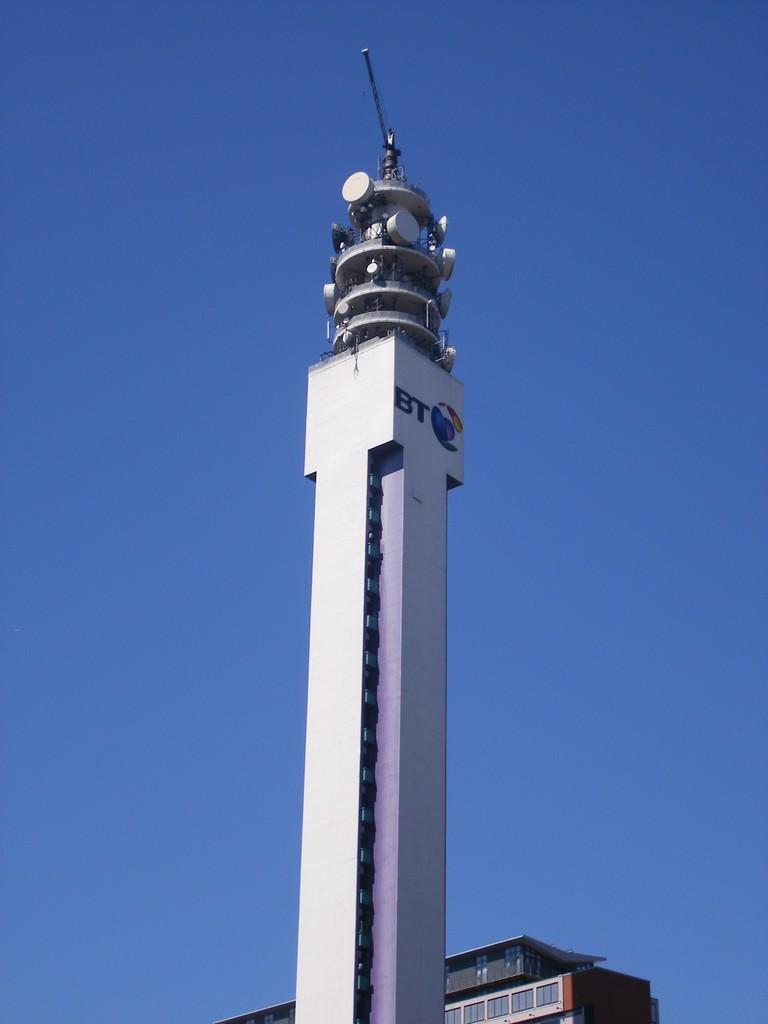What is the main structure in the image? There is a tower in the image. What is located at the top of the tower? An antenna is present at the top of the tower. What can be seen behind the tower? There is a building behind the tower. What is visible in the background of the image? The sky is visible as the background in the image. How does the tower express its feelings of shame in the image? The tower does not express any feelings in the image, as it is an inanimate object. 